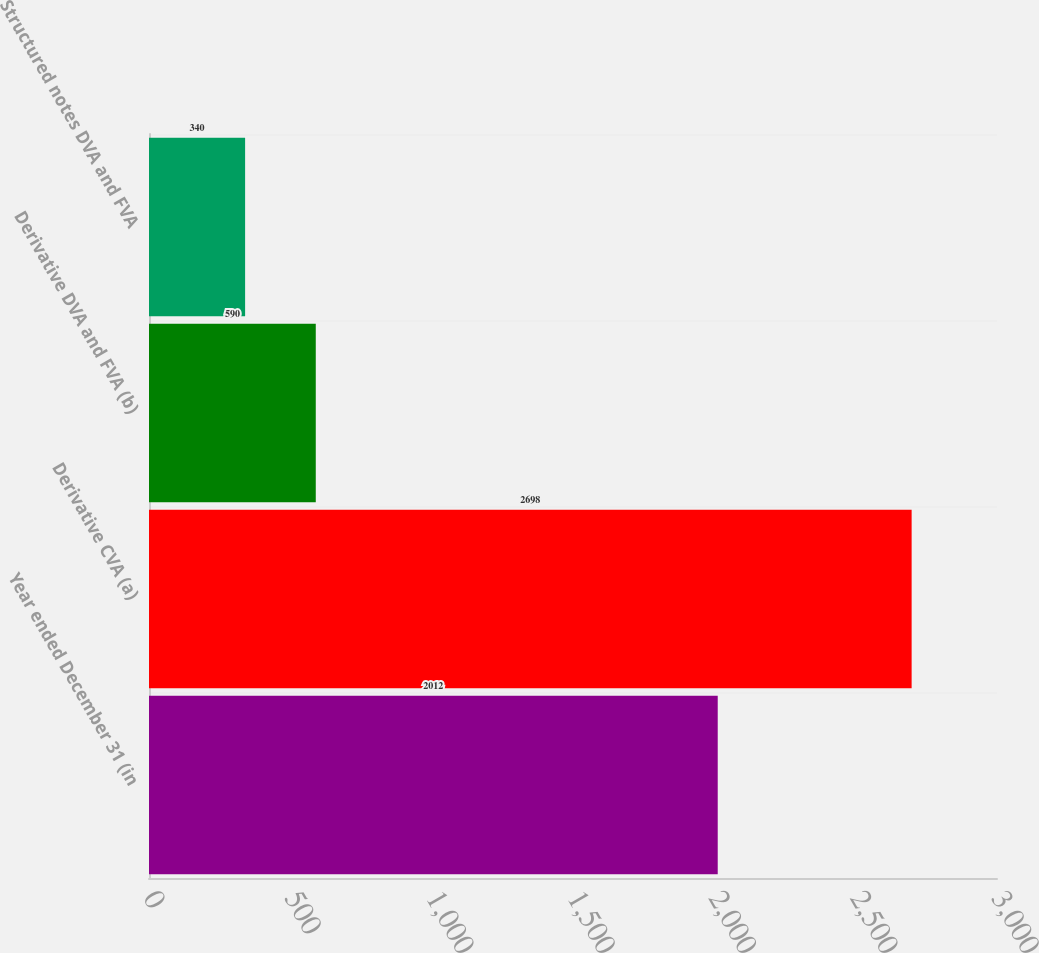Convert chart. <chart><loc_0><loc_0><loc_500><loc_500><bar_chart><fcel>Year ended December 31 (in<fcel>Derivative CVA (a)<fcel>Derivative DVA and FVA (b)<fcel>Structured notes DVA and FVA<nl><fcel>2012<fcel>2698<fcel>590<fcel>340<nl></chart> 